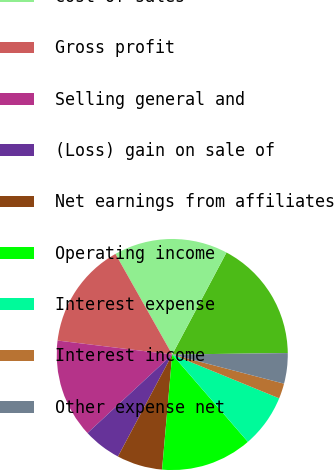<chart> <loc_0><loc_0><loc_500><loc_500><pie_chart><fcel>Sales<fcel>Cost of sales<fcel>Gross profit<fcel>Selling general and<fcel>(Loss) gain on sale of<fcel>Net earnings from affiliates<fcel>Operating income<fcel>Interest expense<fcel>Interest income<fcel>Other expense net<nl><fcel>17.02%<fcel>15.96%<fcel>14.89%<fcel>13.83%<fcel>5.32%<fcel>6.38%<fcel>12.77%<fcel>7.45%<fcel>2.13%<fcel>4.26%<nl></chart> 